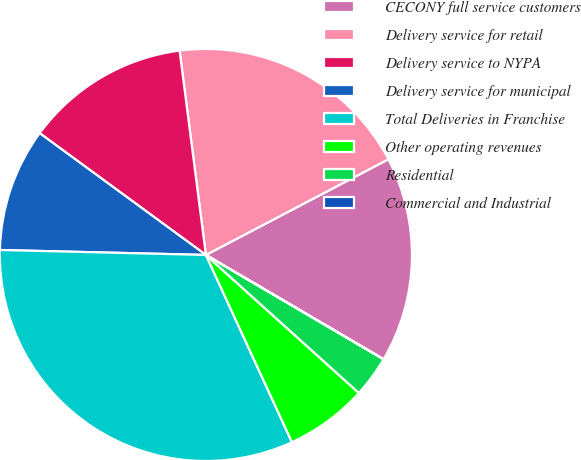<chart> <loc_0><loc_0><loc_500><loc_500><pie_chart><fcel>CECONY full service customers<fcel>Delivery service for retail<fcel>Delivery service to NYPA<fcel>Delivery service for municipal<fcel>Total Deliveries in Franchise<fcel>Other operating revenues<fcel>Residential<fcel>Commercial and Industrial<nl><fcel>16.13%<fcel>19.35%<fcel>12.9%<fcel>9.68%<fcel>32.24%<fcel>6.46%<fcel>3.23%<fcel>0.01%<nl></chart> 